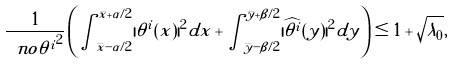Convert formula to latex. <formula><loc_0><loc_0><loc_500><loc_500>\frac { 1 } { \ n o { \theta ^ { i } } ^ { 2 } } \left ( \int _ { \bar { x } - \alpha / 2 } ^ { \bar { x } + \alpha / 2 } | \theta ^ { i } ( x ) | ^ { 2 } d x + \int _ { \bar { y } - \beta / 2 } ^ { \bar { y } + \beta / 2 } | \widehat { \theta ^ { i } } ( y ) | ^ { 2 } d y \right ) \leq 1 + \sqrt { \lambda _ { 0 } } ,</formula> 